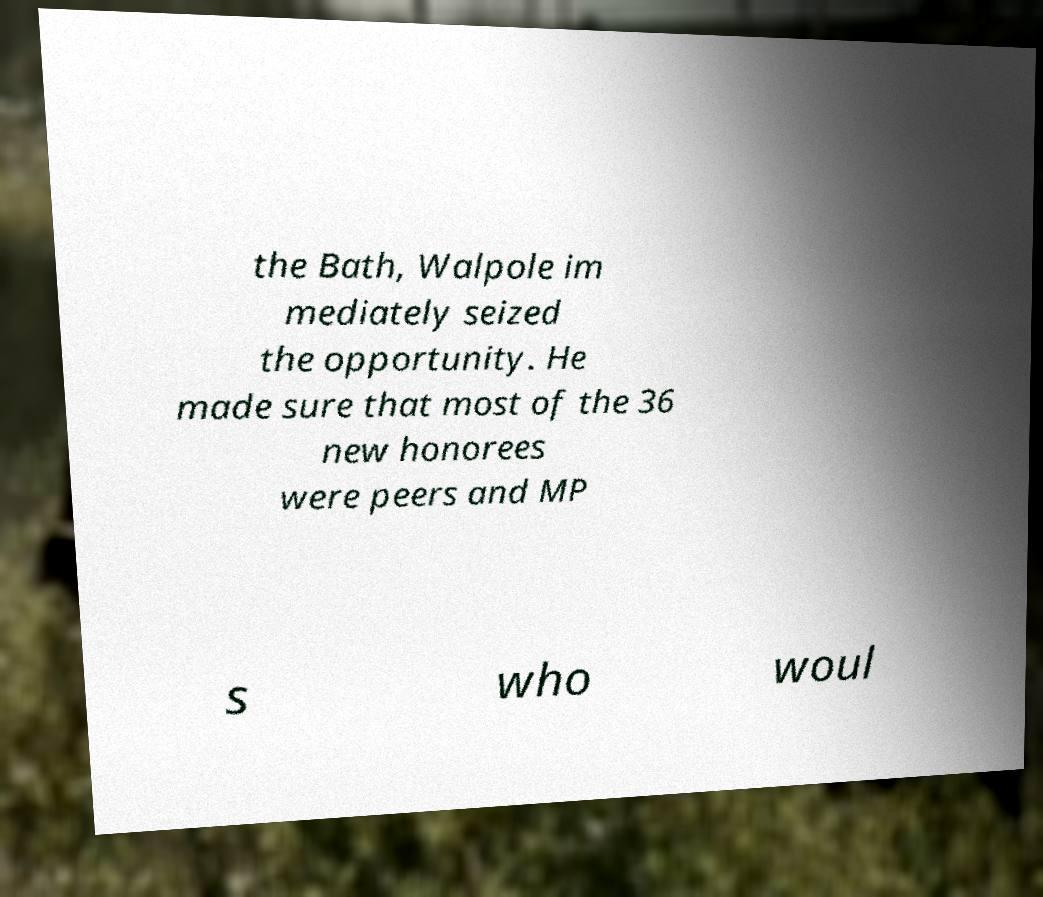Can you accurately transcribe the text from the provided image for me? the Bath, Walpole im mediately seized the opportunity. He made sure that most of the 36 new honorees were peers and MP s who woul 